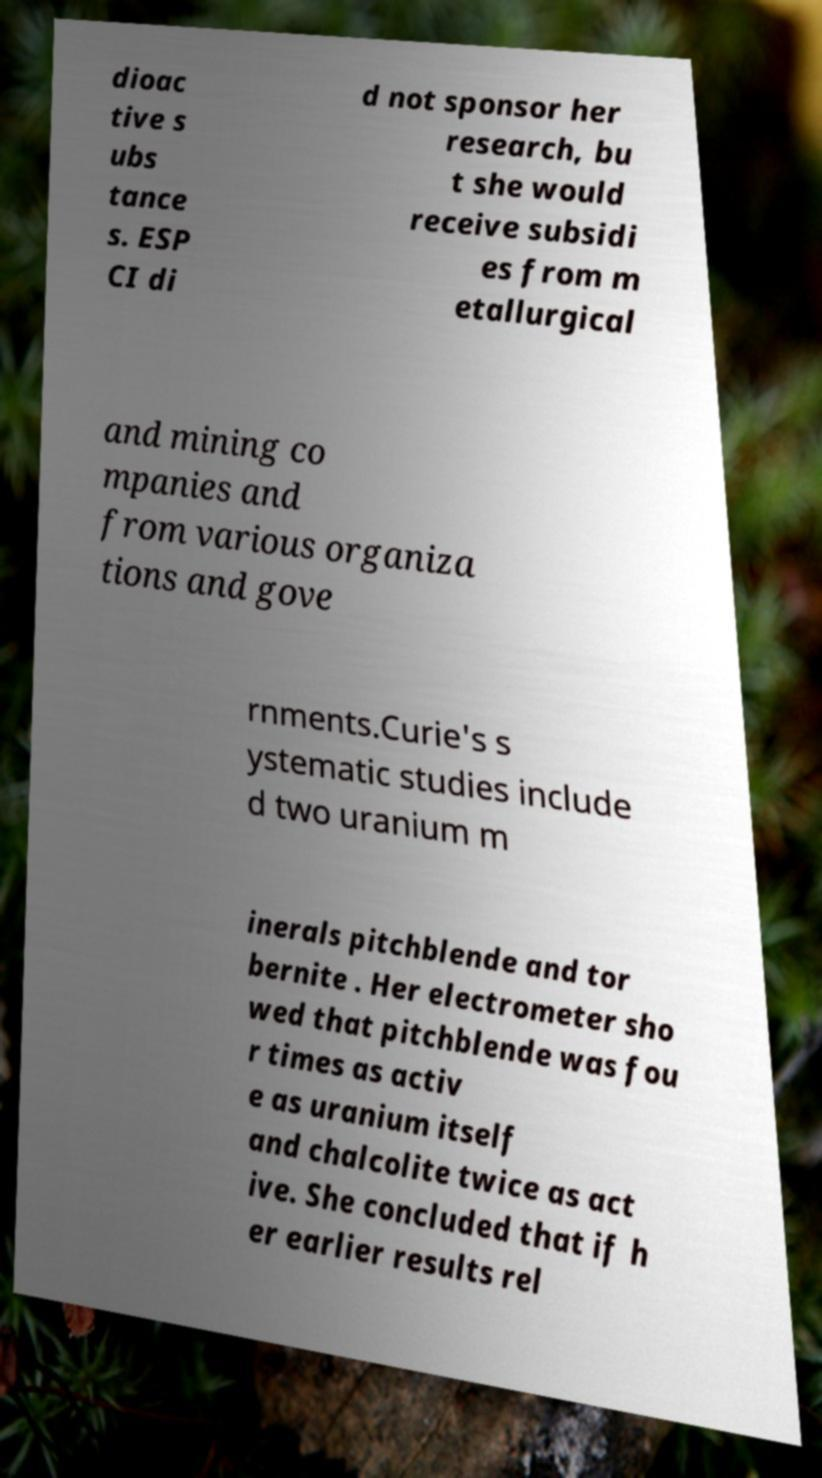What messages or text are displayed in this image? I need them in a readable, typed format. dioac tive s ubs tance s. ESP CI di d not sponsor her research, bu t she would receive subsidi es from m etallurgical and mining co mpanies and from various organiza tions and gove rnments.Curie's s ystematic studies include d two uranium m inerals pitchblende and tor bernite . Her electrometer sho wed that pitchblende was fou r times as activ e as uranium itself and chalcolite twice as act ive. She concluded that if h er earlier results rel 